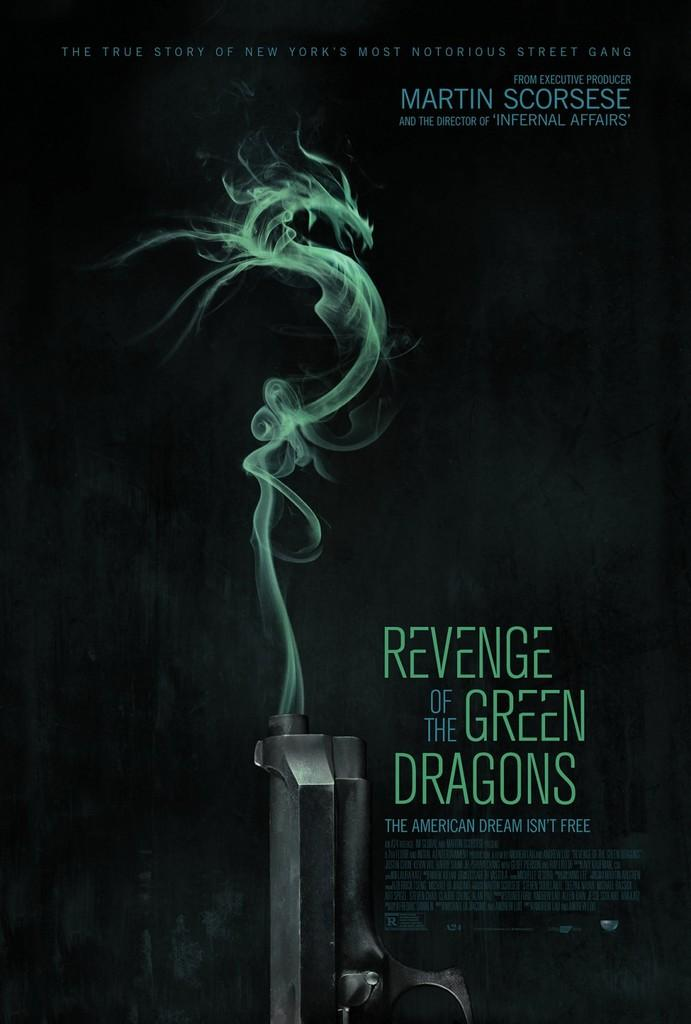What object is present in the image that could be used as a weapon? There is a gun in the image. What is happening to the gun in the image? Smoke is coming out of the gun. Where can text be found in the image? There is text on the right side of the image and above the gun. What type of pot is being used to ride the horse on the dock in the image? There is no pot, horse, or dock present in the image. 